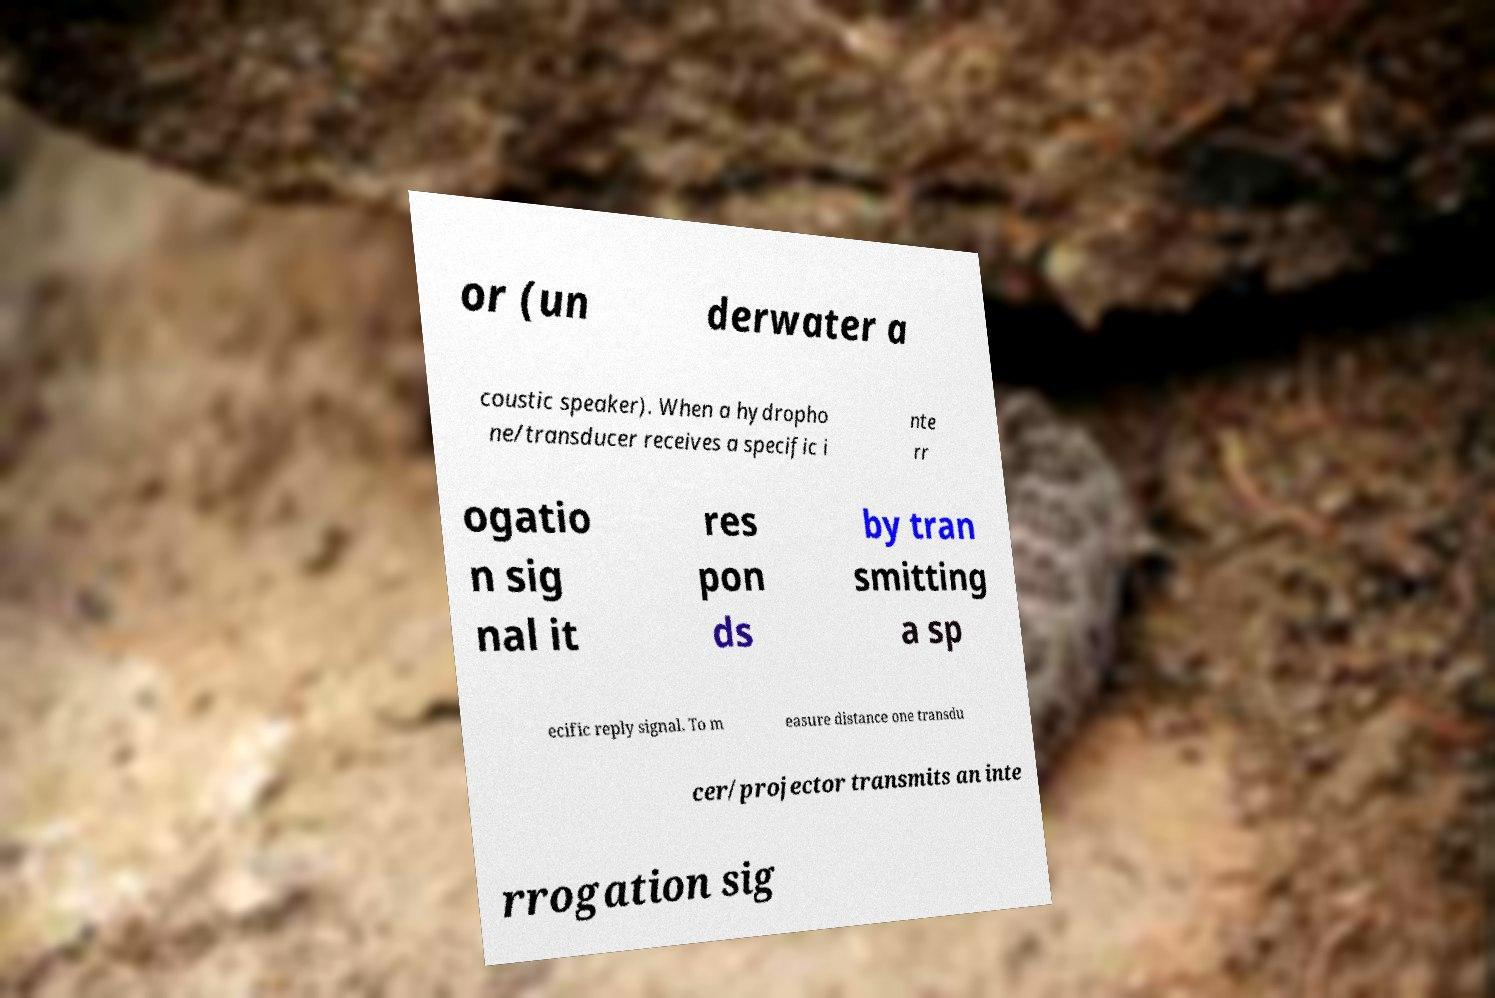I need the written content from this picture converted into text. Can you do that? or (un derwater a coustic speaker). When a hydropho ne/transducer receives a specific i nte rr ogatio n sig nal it res pon ds by tran smitting a sp ecific reply signal. To m easure distance one transdu cer/projector transmits an inte rrogation sig 